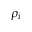Convert formula to latex. <formula><loc_0><loc_0><loc_500><loc_500>\rho _ { i }</formula> 